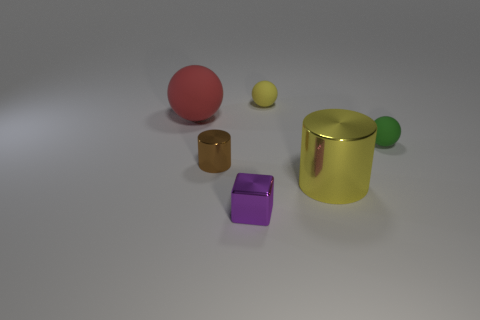Add 2 yellow cylinders. How many objects exist? 8 Subtract all big spheres. How many spheres are left? 2 Subtract all blocks. How many objects are left? 5 Subtract 1 cubes. How many cubes are left? 0 Subtract all red cylinders. How many yellow blocks are left? 0 Subtract all purple shiny objects. Subtract all large yellow cylinders. How many objects are left? 4 Add 2 yellow rubber spheres. How many yellow rubber spheres are left? 3 Add 1 large blue matte blocks. How many large blue matte blocks exist? 1 Subtract all yellow spheres. How many spheres are left? 2 Subtract 0 green cylinders. How many objects are left? 6 